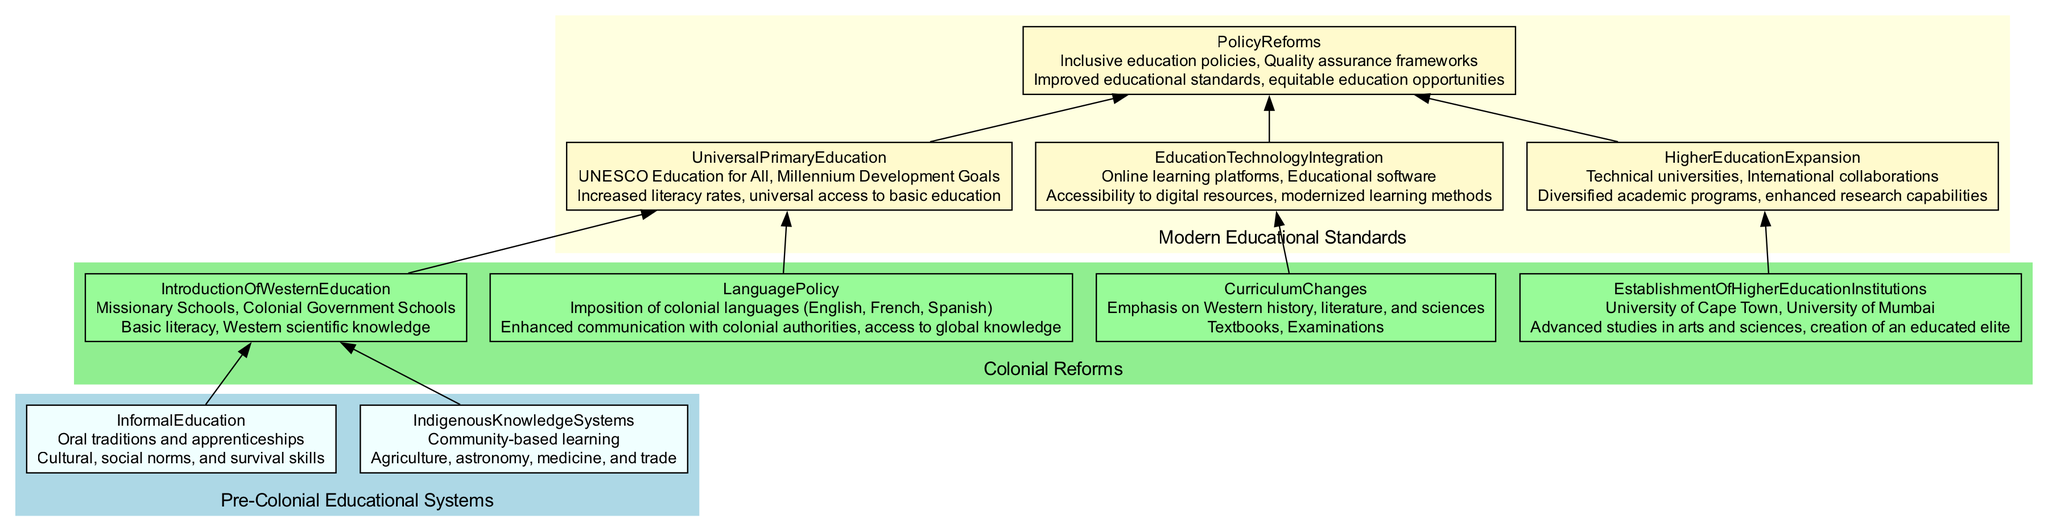What are the two types of pre-colonial educational systems? The diagram lists "Informal Education" and "Indigenous Knowledge Systems" as the two educational systems. These systems are shown at the bottom of the flow chart, indicating their foundational role in pre-colonial education.
Answer: Informal Education, Indigenous Knowledge Systems What impact did Colonial Reforms have on literacy? According to the diagram, the "Introduction of Western Education" led to "Basic literacy" as one of its impacts. This indicates that the reforms directly enhanced literacy levels among the populations in colonized nations.
Answer: Basic literacy Which language policies were imposed during colonization? The diagram specifies "Imposition of colonial languages (English, French, Spanish)" under the Category of Language Policy, indicating the languages that were enforced in the educational context during colonization.
Answer: English, French, Spanish How many higher education institutions are mentioned? The flow chart lists "University of Cape Town" and "University of Mumbai" as examples under the "Establishment of Higher Education Institutions," therefore there are two institutions mentioned in total.
Answer: 2 What is the outcome of Universal Primary Education? The outcome listed in the diagram for "Universal Primary Education" is "Increased literacy rates, universal access to basic education," which denotes the primary goal achieved through this educational reform.
Answer: Increased literacy rates, universal access to basic education What leads to the establishment of policy reforms in modern education? The diagram shows that both "Universal Primary Education" and "Education Technology Integration" flow into "Policy Reforms," indicating that these two factors contribute to the establishment of policy reforms in modern educational standards.
Answer: Universal Primary Education, Education Technology Integration Which educational standards focus on digital resources? The "Education Technology Integration" node is dedicated to modernizing education through digital means, highlighting the integration of "Online learning platforms" and "Educational software" specifically aimed at enhancing digital resource accessibility.
Answer: Education Technology Integration What entities are involved in the higher education expansion? The diagram identifies "Technical universities" and "International collaborations" as the entities associated with "Higher Education Expansion," implying that these elements are crucial for developing advanced academic structures and relationships.
Answer: Technical universities, International collaborations What connects the pre-colonial education to modern educational frameworks? The flow of the diagram illustrates that both "Informal Education" and "Indigenous Knowledge Systems" lead into "Introduction of Western Education,” which marks the transition from pre-colonial educational systems to the context of modern educational frameworks following colonial influences.
Answer: Introduction of Western Education 